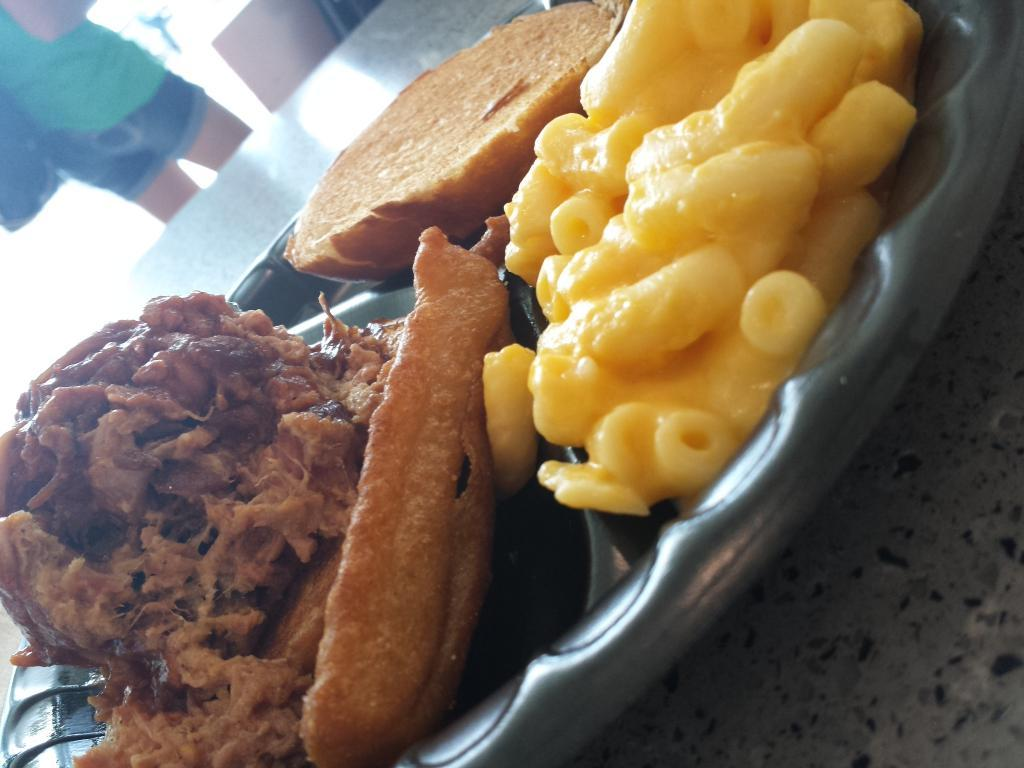What is on the plate that is visible in the image? There is food in a plate in the image. What piece of furniture is present in the image? There is a table in the image. Can you describe the human in the background of the image? Unfortunately, the facts provided do not give any details about the human in the background. What type of lumber is being used to construct the hen's nest in the image? There is no hen or nest present in the image, so it is not possible to answer that question. 